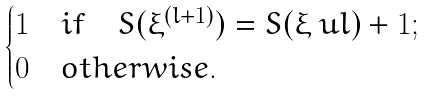<formula> <loc_0><loc_0><loc_500><loc_500>\begin{cases} 1 & i f \quad S ( \xi ^ { ( l + 1 ) } ) = S ( \xi \ u l ) + 1 ; \\ 0 & o t h e r w i s e . \end{cases}</formula> 